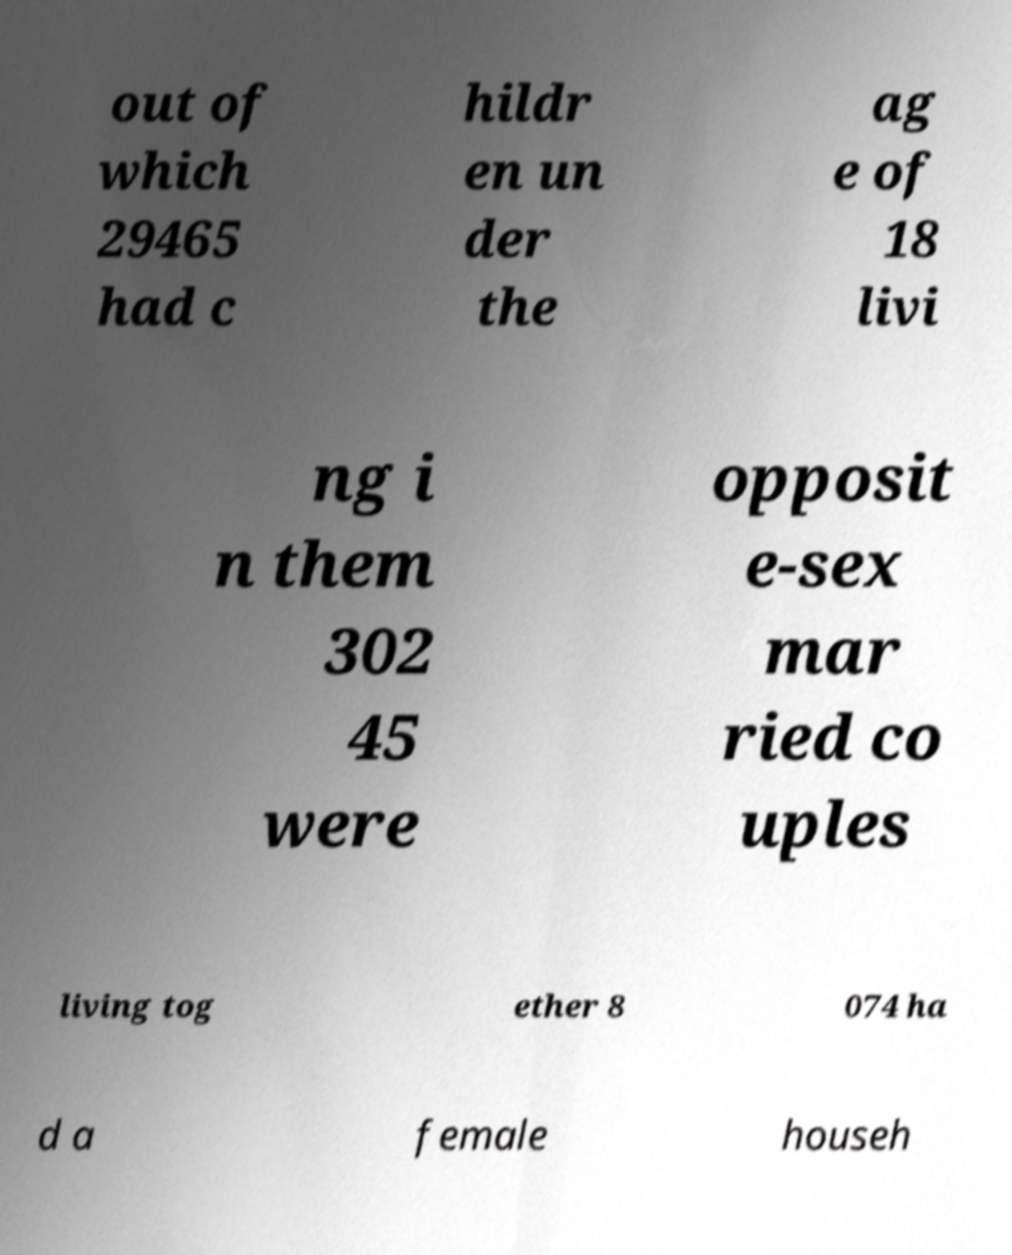For documentation purposes, I need the text within this image transcribed. Could you provide that? out of which 29465 had c hildr en un der the ag e of 18 livi ng i n them 302 45 were opposit e-sex mar ried co uples living tog ether 8 074 ha d a female househ 